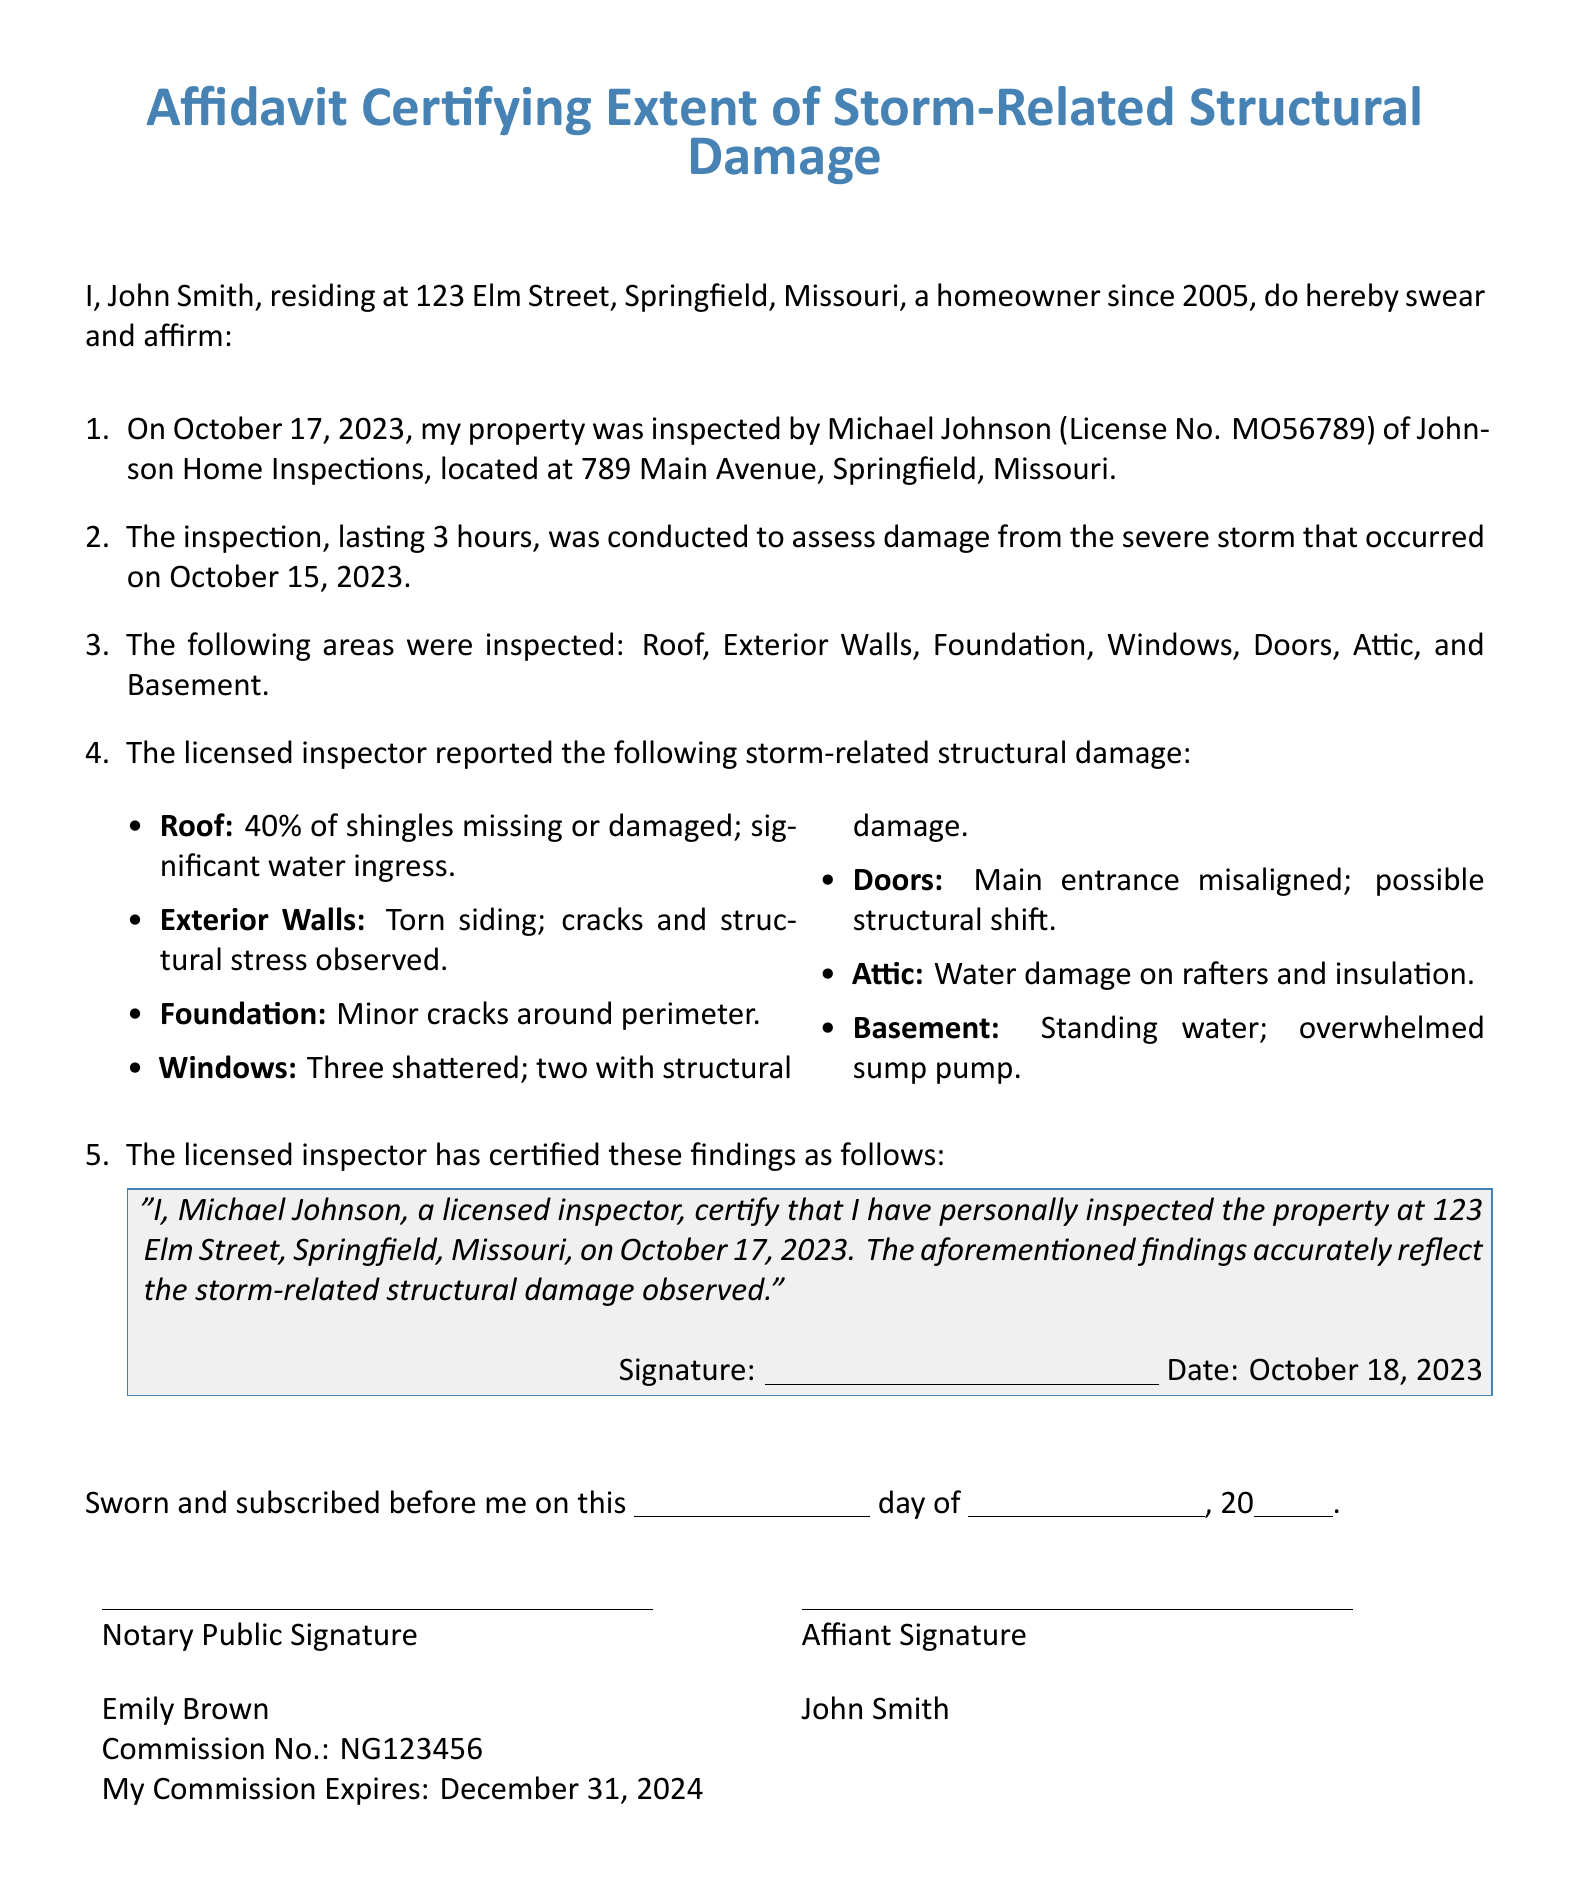What is the name of the homeowner? The homeowner's name is stated at the beginning of the document.
Answer: John Smith What is the date of the property inspection? The document specifies the date when the inspection was conducted.
Answer: October 17, 2023 Who conducted the inspection? The name of the licensed inspector is mentioned in the document.
Answer: Michael Johnson What percentage of shingles are reported missing or damaged? The document provides a specific percentage regarding the roof damage.
Answer: 40% How many shattered windows were reported? The number of shattered windows is clearly stated in the inspection report.
Answer: Three What is the main problem reported in the attic? The document details a specific issue related to the attic after the storm.
Answer: Water damage What is the commission expiry date for the notary public? The document provides the expiry date of the notary's commission.
Answer: December 31, 2024 Who is the notary public for this affidavit? The document lists the name of the notary public.
Answer: Emily Brown What structural issue is noted with the main entrance? The findings of the inspection discuss a specific problem with the main entrance.
Answer: Misaligned 